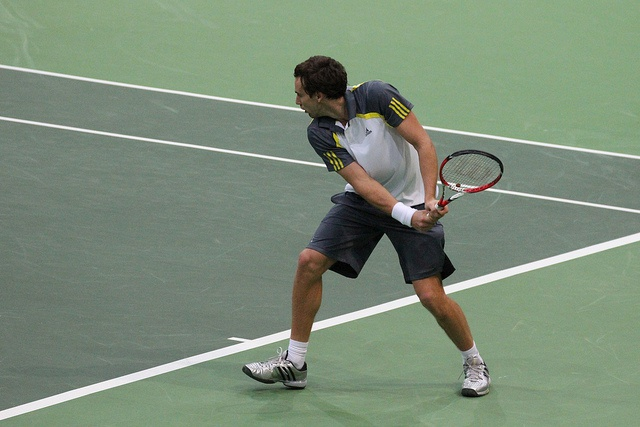Describe the objects in this image and their specific colors. I can see people in darkgray, black, gray, and maroon tones and tennis racket in darkgray, gray, and black tones in this image. 